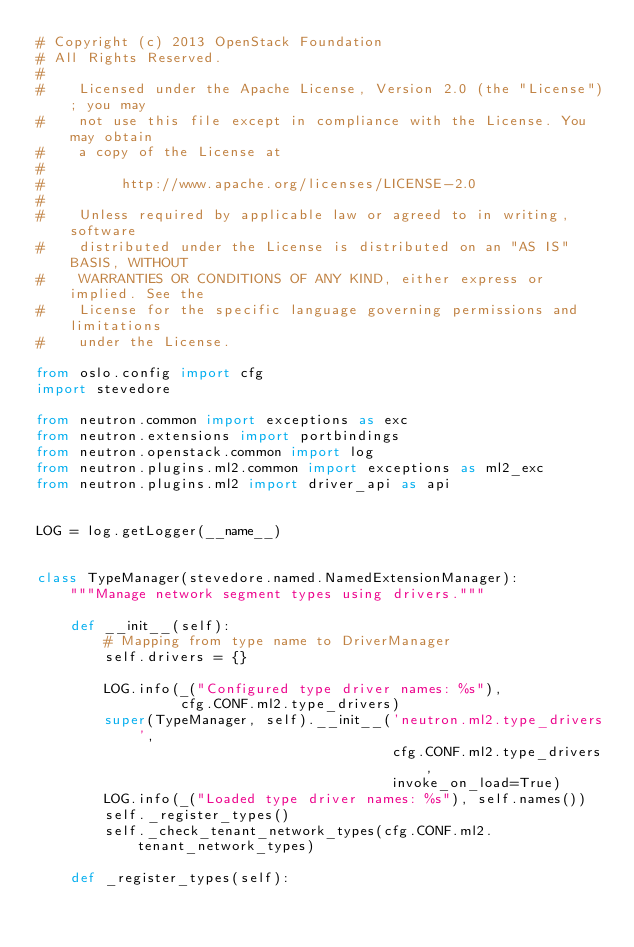Convert code to text. <code><loc_0><loc_0><loc_500><loc_500><_Python_># Copyright (c) 2013 OpenStack Foundation
# All Rights Reserved.
#
#    Licensed under the Apache License, Version 2.0 (the "License"); you may
#    not use this file except in compliance with the License. You may obtain
#    a copy of the License at
#
#         http://www.apache.org/licenses/LICENSE-2.0
#
#    Unless required by applicable law or agreed to in writing, software
#    distributed under the License is distributed on an "AS IS" BASIS, WITHOUT
#    WARRANTIES OR CONDITIONS OF ANY KIND, either express or implied. See the
#    License for the specific language governing permissions and limitations
#    under the License.

from oslo.config import cfg
import stevedore

from neutron.common import exceptions as exc
from neutron.extensions import portbindings
from neutron.openstack.common import log
from neutron.plugins.ml2.common import exceptions as ml2_exc
from neutron.plugins.ml2 import driver_api as api


LOG = log.getLogger(__name__)


class TypeManager(stevedore.named.NamedExtensionManager):
    """Manage network segment types using drivers."""

    def __init__(self):
        # Mapping from type name to DriverManager
        self.drivers = {}

        LOG.info(_("Configured type driver names: %s"),
                 cfg.CONF.ml2.type_drivers)
        super(TypeManager, self).__init__('neutron.ml2.type_drivers',
                                          cfg.CONF.ml2.type_drivers,
                                          invoke_on_load=True)
        LOG.info(_("Loaded type driver names: %s"), self.names())
        self._register_types()
        self._check_tenant_network_types(cfg.CONF.ml2.tenant_network_types)

    def _register_types(self):</code> 